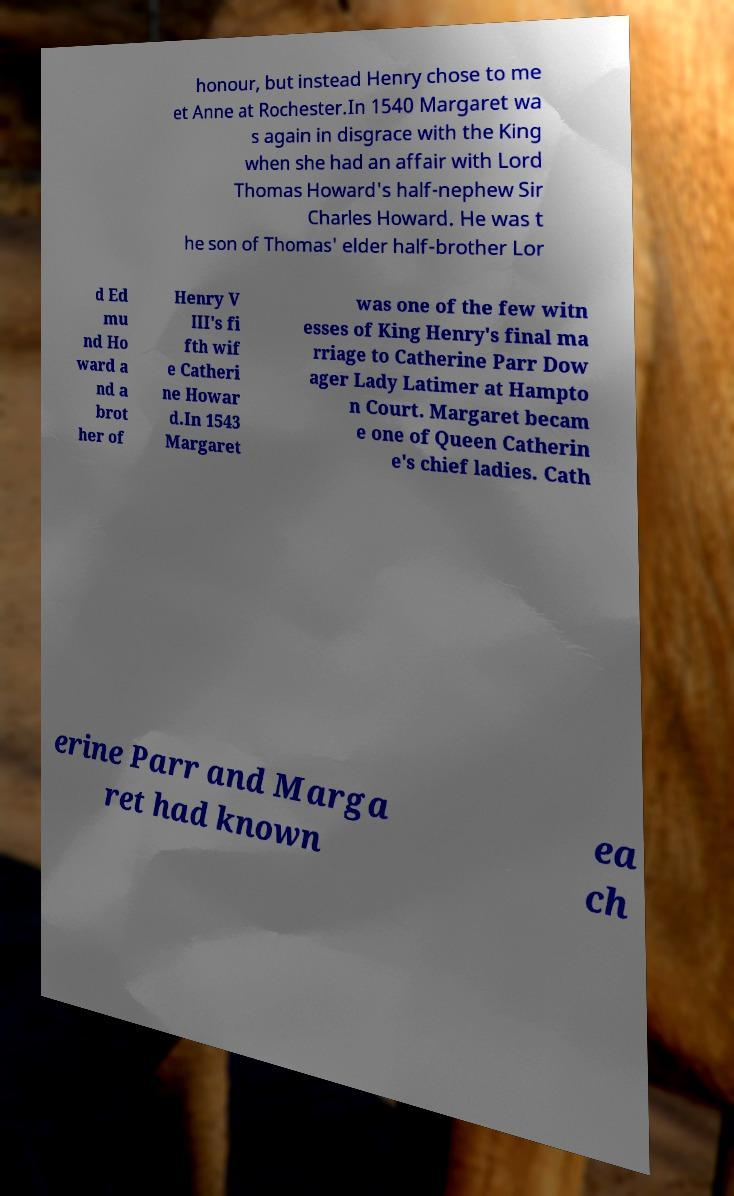Can you accurately transcribe the text from the provided image for me? honour, but instead Henry chose to me et Anne at Rochester.In 1540 Margaret wa s again in disgrace with the King when she had an affair with Lord Thomas Howard's half-nephew Sir Charles Howard. He was t he son of Thomas' elder half-brother Lor d Ed mu nd Ho ward a nd a brot her of Henry V III's fi fth wif e Catheri ne Howar d.In 1543 Margaret was one of the few witn esses of King Henry's final ma rriage to Catherine Parr Dow ager Lady Latimer at Hampto n Court. Margaret becam e one of Queen Catherin e's chief ladies. Cath erine Parr and Marga ret had known ea ch 